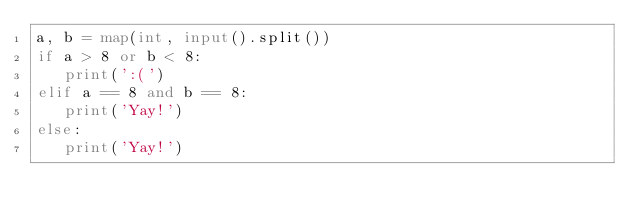Convert code to text. <code><loc_0><loc_0><loc_500><loc_500><_Python_>a, b = map(int, input().split())
if a > 8 or b < 8:
   print(':(')
elif a == 8 and b == 8:
   print('Yay!')
else:
   print('Yay!')
</code> 